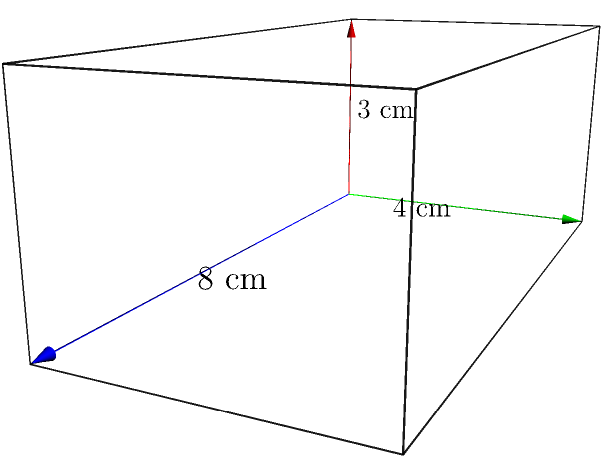As a first responder, you need to calculate the volume of a rectangular prism-shaped medication storage container for your emergency kit. The container measures 8 cm in length, 4 cm in width, and 3 cm in height. What is the volume of this container in cubic centimeters? To find the volume of a rectangular prism, we use the formula:

$$V = l \times w \times h$$

Where:
- $V$ is the volume
- $l$ is the length
- $w$ is the width
- $h$ is the height

Given dimensions:
- Length ($l$) = 8 cm
- Width ($w$) = 4 cm
- Height ($h$) = 3 cm

Let's substitute these values into the formula:

$$V = 8 \text{ cm} \times 4 \text{ cm} \times 3 \text{ cm}$$

Multiplying these numbers:

$$V = 96 \text{ cm}^3$$

Therefore, the volume of the medication storage container is 96 cubic centimeters.
Answer: 96 cm³ 